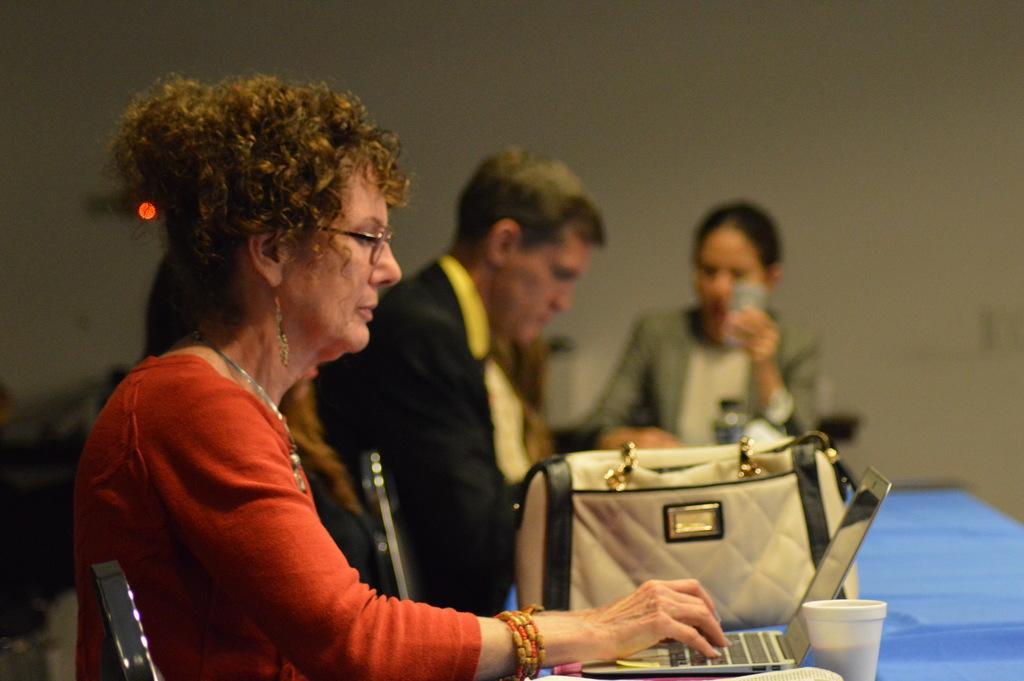Could you give a brief overview of what you see in this image? In this image, we can see group of people are sat on the chair. At the bottom, there is a blue color table, few items are placed on it. And the right side, woman is holding something on his hand. Background, there is a white wall. 